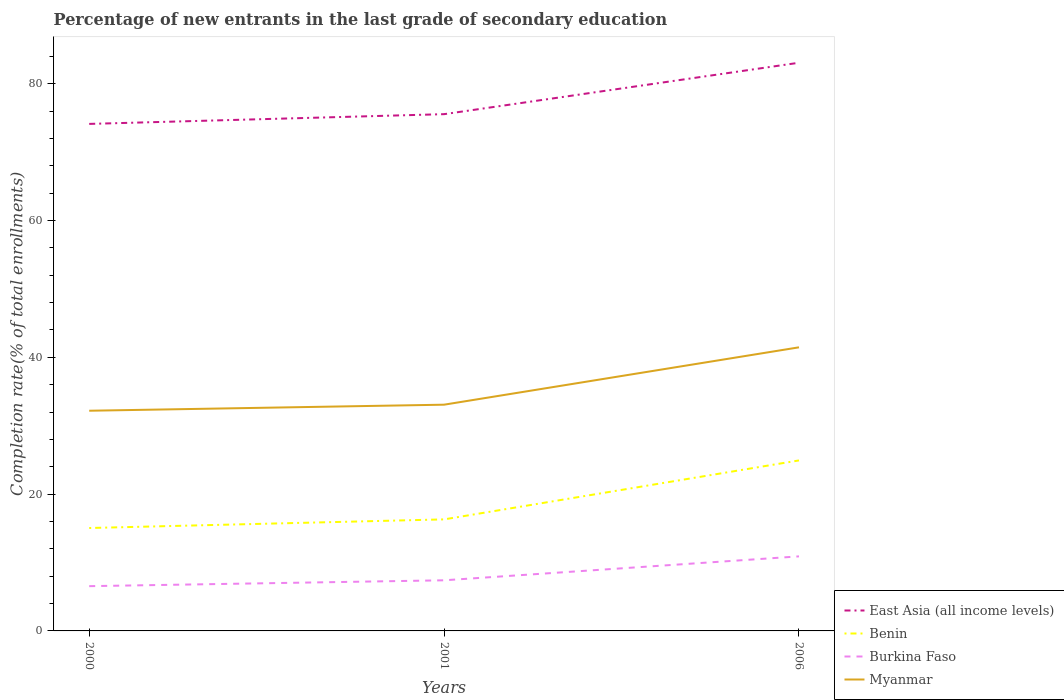Does the line corresponding to East Asia (all income levels) intersect with the line corresponding to Benin?
Offer a terse response. No. Is the number of lines equal to the number of legend labels?
Ensure brevity in your answer.  Yes. Across all years, what is the maximum percentage of new entrants in Burkina Faso?
Keep it short and to the point. 6.54. What is the total percentage of new entrants in Benin in the graph?
Your answer should be compact. -9.88. What is the difference between the highest and the second highest percentage of new entrants in Myanmar?
Your answer should be compact. 9.27. What is the difference between the highest and the lowest percentage of new entrants in East Asia (all income levels)?
Your answer should be very brief. 1. What is the difference between two consecutive major ticks on the Y-axis?
Provide a succinct answer. 20. Does the graph contain any zero values?
Your answer should be compact. No. How are the legend labels stacked?
Provide a short and direct response. Vertical. What is the title of the graph?
Ensure brevity in your answer.  Percentage of new entrants in the last grade of secondary education. What is the label or title of the X-axis?
Your answer should be compact. Years. What is the label or title of the Y-axis?
Keep it short and to the point. Completion rate(% of total enrollments). What is the Completion rate(% of total enrollments) of East Asia (all income levels) in 2000?
Your response must be concise. 74.12. What is the Completion rate(% of total enrollments) of Benin in 2000?
Offer a terse response. 15.04. What is the Completion rate(% of total enrollments) in Burkina Faso in 2000?
Provide a short and direct response. 6.54. What is the Completion rate(% of total enrollments) of Myanmar in 2000?
Offer a very short reply. 32.19. What is the Completion rate(% of total enrollments) in East Asia (all income levels) in 2001?
Your answer should be compact. 75.54. What is the Completion rate(% of total enrollments) of Benin in 2001?
Give a very brief answer. 16.31. What is the Completion rate(% of total enrollments) of Burkina Faso in 2001?
Your response must be concise. 7.4. What is the Completion rate(% of total enrollments) of Myanmar in 2001?
Give a very brief answer. 33.07. What is the Completion rate(% of total enrollments) in East Asia (all income levels) in 2006?
Give a very brief answer. 83.06. What is the Completion rate(% of total enrollments) in Benin in 2006?
Your answer should be compact. 24.92. What is the Completion rate(% of total enrollments) of Burkina Faso in 2006?
Provide a short and direct response. 10.9. What is the Completion rate(% of total enrollments) of Myanmar in 2006?
Make the answer very short. 41.46. Across all years, what is the maximum Completion rate(% of total enrollments) of East Asia (all income levels)?
Keep it short and to the point. 83.06. Across all years, what is the maximum Completion rate(% of total enrollments) of Benin?
Provide a succinct answer. 24.92. Across all years, what is the maximum Completion rate(% of total enrollments) of Burkina Faso?
Make the answer very short. 10.9. Across all years, what is the maximum Completion rate(% of total enrollments) in Myanmar?
Make the answer very short. 41.46. Across all years, what is the minimum Completion rate(% of total enrollments) in East Asia (all income levels)?
Your response must be concise. 74.12. Across all years, what is the minimum Completion rate(% of total enrollments) of Benin?
Make the answer very short. 15.04. Across all years, what is the minimum Completion rate(% of total enrollments) of Burkina Faso?
Provide a succinct answer. 6.54. Across all years, what is the minimum Completion rate(% of total enrollments) in Myanmar?
Provide a short and direct response. 32.19. What is the total Completion rate(% of total enrollments) in East Asia (all income levels) in the graph?
Your answer should be compact. 232.71. What is the total Completion rate(% of total enrollments) of Benin in the graph?
Ensure brevity in your answer.  56.27. What is the total Completion rate(% of total enrollments) of Burkina Faso in the graph?
Ensure brevity in your answer.  24.84. What is the total Completion rate(% of total enrollments) of Myanmar in the graph?
Offer a terse response. 106.72. What is the difference between the Completion rate(% of total enrollments) in East Asia (all income levels) in 2000 and that in 2001?
Offer a terse response. -1.43. What is the difference between the Completion rate(% of total enrollments) of Benin in 2000 and that in 2001?
Keep it short and to the point. -1.26. What is the difference between the Completion rate(% of total enrollments) of Burkina Faso in 2000 and that in 2001?
Provide a short and direct response. -0.86. What is the difference between the Completion rate(% of total enrollments) in Myanmar in 2000 and that in 2001?
Your answer should be very brief. -0.88. What is the difference between the Completion rate(% of total enrollments) of East Asia (all income levels) in 2000 and that in 2006?
Your response must be concise. -8.94. What is the difference between the Completion rate(% of total enrollments) of Benin in 2000 and that in 2006?
Provide a succinct answer. -9.88. What is the difference between the Completion rate(% of total enrollments) of Burkina Faso in 2000 and that in 2006?
Offer a terse response. -4.35. What is the difference between the Completion rate(% of total enrollments) in Myanmar in 2000 and that in 2006?
Your answer should be very brief. -9.27. What is the difference between the Completion rate(% of total enrollments) of East Asia (all income levels) in 2001 and that in 2006?
Your answer should be very brief. -7.52. What is the difference between the Completion rate(% of total enrollments) in Benin in 2001 and that in 2006?
Ensure brevity in your answer.  -8.62. What is the difference between the Completion rate(% of total enrollments) of Burkina Faso in 2001 and that in 2006?
Offer a very short reply. -3.5. What is the difference between the Completion rate(% of total enrollments) of Myanmar in 2001 and that in 2006?
Offer a terse response. -8.39. What is the difference between the Completion rate(% of total enrollments) in East Asia (all income levels) in 2000 and the Completion rate(% of total enrollments) in Benin in 2001?
Keep it short and to the point. 57.81. What is the difference between the Completion rate(% of total enrollments) in East Asia (all income levels) in 2000 and the Completion rate(% of total enrollments) in Burkina Faso in 2001?
Your answer should be compact. 66.71. What is the difference between the Completion rate(% of total enrollments) in East Asia (all income levels) in 2000 and the Completion rate(% of total enrollments) in Myanmar in 2001?
Offer a very short reply. 41.04. What is the difference between the Completion rate(% of total enrollments) of Benin in 2000 and the Completion rate(% of total enrollments) of Burkina Faso in 2001?
Provide a succinct answer. 7.64. What is the difference between the Completion rate(% of total enrollments) of Benin in 2000 and the Completion rate(% of total enrollments) of Myanmar in 2001?
Your response must be concise. -18.03. What is the difference between the Completion rate(% of total enrollments) of Burkina Faso in 2000 and the Completion rate(% of total enrollments) of Myanmar in 2001?
Keep it short and to the point. -26.53. What is the difference between the Completion rate(% of total enrollments) in East Asia (all income levels) in 2000 and the Completion rate(% of total enrollments) in Benin in 2006?
Your answer should be compact. 49.19. What is the difference between the Completion rate(% of total enrollments) in East Asia (all income levels) in 2000 and the Completion rate(% of total enrollments) in Burkina Faso in 2006?
Offer a very short reply. 63.22. What is the difference between the Completion rate(% of total enrollments) of East Asia (all income levels) in 2000 and the Completion rate(% of total enrollments) of Myanmar in 2006?
Offer a terse response. 32.66. What is the difference between the Completion rate(% of total enrollments) in Benin in 2000 and the Completion rate(% of total enrollments) in Burkina Faso in 2006?
Your answer should be compact. 4.15. What is the difference between the Completion rate(% of total enrollments) of Benin in 2000 and the Completion rate(% of total enrollments) of Myanmar in 2006?
Ensure brevity in your answer.  -26.41. What is the difference between the Completion rate(% of total enrollments) in Burkina Faso in 2000 and the Completion rate(% of total enrollments) in Myanmar in 2006?
Keep it short and to the point. -34.91. What is the difference between the Completion rate(% of total enrollments) of East Asia (all income levels) in 2001 and the Completion rate(% of total enrollments) of Benin in 2006?
Give a very brief answer. 50.62. What is the difference between the Completion rate(% of total enrollments) of East Asia (all income levels) in 2001 and the Completion rate(% of total enrollments) of Burkina Faso in 2006?
Offer a very short reply. 64.64. What is the difference between the Completion rate(% of total enrollments) of East Asia (all income levels) in 2001 and the Completion rate(% of total enrollments) of Myanmar in 2006?
Ensure brevity in your answer.  34.08. What is the difference between the Completion rate(% of total enrollments) in Benin in 2001 and the Completion rate(% of total enrollments) in Burkina Faso in 2006?
Make the answer very short. 5.41. What is the difference between the Completion rate(% of total enrollments) in Benin in 2001 and the Completion rate(% of total enrollments) in Myanmar in 2006?
Your answer should be compact. -25.15. What is the difference between the Completion rate(% of total enrollments) of Burkina Faso in 2001 and the Completion rate(% of total enrollments) of Myanmar in 2006?
Provide a short and direct response. -34.06. What is the average Completion rate(% of total enrollments) of East Asia (all income levels) per year?
Provide a short and direct response. 77.57. What is the average Completion rate(% of total enrollments) of Benin per year?
Keep it short and to the point. 18.76. What is the average Completion rate(% of total enrollments) of Burkina Faso per year?
Provide a succinct answer. 8.28. What is the average Completion rate(% of total enrollments) in Myanmar per year?
Keep it short and to the point. 35.57. In the year 2000, what is the difference between the Completion rate(% of total enrollments) in East Asia (all income levels) and Completion rate(% of total enrollments) in Benin?
Provide a succinct answer. 59.07. In the year 2000, what is the difference between the Completion rate(% of total enrollments) of East Asia (all income levels) and Completion rate(% of total enrollments) of Burkina Faso?
Your response must be concise. 67.57. In the year 2000, what is the difference between the Completion rate(% of total enrollments) of East Asia (all income levels) and Completion rate(% of total enrollments) of Myanmar?
Offer a very short reply. 41.93. In the year 2000, what is the difference between the Completion rate(% of total enrollments) of Benin and Completion rate(% of total enrollments) of Burkina Faso?
Your response must be concise. 8.5. In the year 2000, what is the difference between the Completion rate(% of total enrollments) in Benin and Completion rate(% of total enrollments) in Myanmar?
Offer a very short reply. -17.14. In the year 2000, what is the difference between the Completion rate(% of total enrollments) in Burkina Faso and Completion rate(% of total enrollments) in Myanmar?
Make the answer very short. -25.64. In the year 2001, what is the difference between the Completion rate(% of total enrollments) of East Asia (all income levels) and Completion rate(% of total enrollments) of Benin?
Ensure brevity in your answer.  59.24. In the year 2001, what is the difference between the Completion rate(% of total enrollments) of East Asia (all income levels) and Completion rate(% of total enrollments) of Burkina Faso?
Your answer should be compact. 68.14. In the year 2001, what is the difference between the Completion rate(% of total enrollments) of East Asia (all income levels) and Completion rate(% of total enrollments) of Myanmar?
Offer a terse response. 42.47. In the year 2001, what is the difference between the Completion rate(% of total enrollments) in Benin and Completion rate(% of total enrollments) in Burkina Faso?
Your answer should be compact. 8.91. In the year 2001, what is the difference between the Completion rate(% of total enrollments) in Benin and Completion rate(% of total enrollments) in Myanmar?
Offer a terse response. -16.77. In the year 2001, what is the difference between the Completion rate(% of total enrollments) of Burkina Faso and Completion rate(% of total enrollments) of Myanmar?
Provide a short and direct response. -25.67. In the year 2006, what is the difference between the Completion rate(% of total enrollments) of East Asia (all income levels) and Completion rate(% of total enrollments) of Benin?
Keep it short and to the point. 58.13. In the year 2006, what is the difference between the Completion rate(% of total enrollments) of East Asia (all income levels) and Completion rate(% of total enrollments) of Burkina Faso?
Ensure brevity in your answer.  72.16. In the year 2006, what is the difference between the Completion rate(% of total enrollments) of East Asia (all income levels) and Completion rate(% of total enrollments) of Myanmar?
Give a very brief answer. 41.6. In the year 2006, what is the difference between the Completion rate(% of total enrollments) in Benin and Completion rate(% of total enrollments) in Burkina Faso?
Ensure brevity in your answer.  14.03. In the year 2006, what is the difference between the Completion rate(% of total enrollments) of Benin and Completion rate(% of total enrollments) of Myanmar?
Give a very brief answer. -16.53. In the year 2006, what is the difference between the Completion rate(% of total enrollments) in Burkina Faso and Completion rate(% of total enrollments) in Myanmar?
Keep it short and to the point. -30.56. What is the ratio of the Completion rate(% of total enrollments) in East Asia (all income levels) in 2000 to that in 2001?
Keep it short and to the point. 0.98. What is the ratio of the Completion rate(% of total enrollments) in Benin in 2000 to that in 2001?
Your answer should be compact. 0.92. What is the ratio of the Completion rate(% of total enrollments) of Burkina Faso in 2000 to that in 2001?
Provide a succinct answer. 0.88. What is the ratio of the Completion rate(% of total enrollments) in Myanmar in 2000 to that in 2001?
Give a very brief answer. 0.97. What is the ratio of the Completion rate(% of total enrollments) in East Asia (all income levels) in 2000 to that in 2006?
Your answer should be very brief. 0.89. What is the ratio of the Completion rate(% of total enrollments) in Benin in 2000 to that in 2006?
Your response must be concise. 0.6. What is the ratio of the Completion rate(% of total enrollments) of Burkina Faso in 2000 to that in 2006?
Ensure brevity in your answer.  0.6. What is the ratio of the Completion rate(% of total enrollments) of Myanmar in 2000 to that in 2006?
Make the answer very short. 0.78. What is the ratio of the Completion rate(% of total enrollments) in East Asia (all income levels) in 2001 to that in 2006?
Ensure brevity in your answer.  0.91. What is the ratio of the Completion rate(% of total enrollments) in Benin in 2001 to that in 2006?
Your answer should be very brief. 0.65. What is the ratio of the Completion rate(% of total enrollments) of Burkina Faso in 2001 to that in 2006?
Keep it short and to the point. 0.68. What is the ratio of the Completion rate(% of total enrollments) of Myanmar in 2001 to that in 2006?
Your answer should be compact. 0.8. What is the difference between the highest and the second highest Completion rate(% of total enrollments) of East Asia (all income levels)?
Offer a terse response. 7.52. What is the difference between the highest and the second highest Completion rate(% of total enrollments) of Benin?
Offer a very short reply. 8.62. What is the difference between the highest and the second highest Completion rate(% of total enrollments) of Burkina Faso?
Provide a succinct answer. 3.5. What is the difference between the highest and the second highest Completion rate(% of total enrollments) of Myanmar?
Offer a terse response. 8.39. What is the difference between the highest and the lowest Completion rate(% of total enrollments) in East Asia (all income levels)?
Offer a terse response. 8.94. What is the difference between the highest and the lowest Completion rate(% of total enrollments) of Benin?
Your answer should be very brief. 9.88. What is the difference between the highest and the lowest Completion rate(% of total enrollments) of Burkina Faso?
Provide a succinct answer. 4.35. What is the difference between the highest and the lowest Completion rate(% of total enrollments) in Myanmar?
Provide a succinct answer. 9.27. 